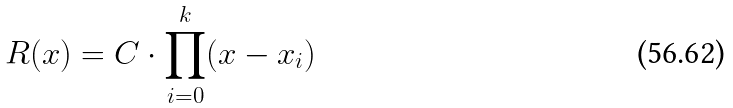<formula> <loc_0><loc_0><loc_500><loc_500>R ( x ) = C \cdot \prod _ { i = 0 } ^ { k } ( x - x _ { i } )</formula> 